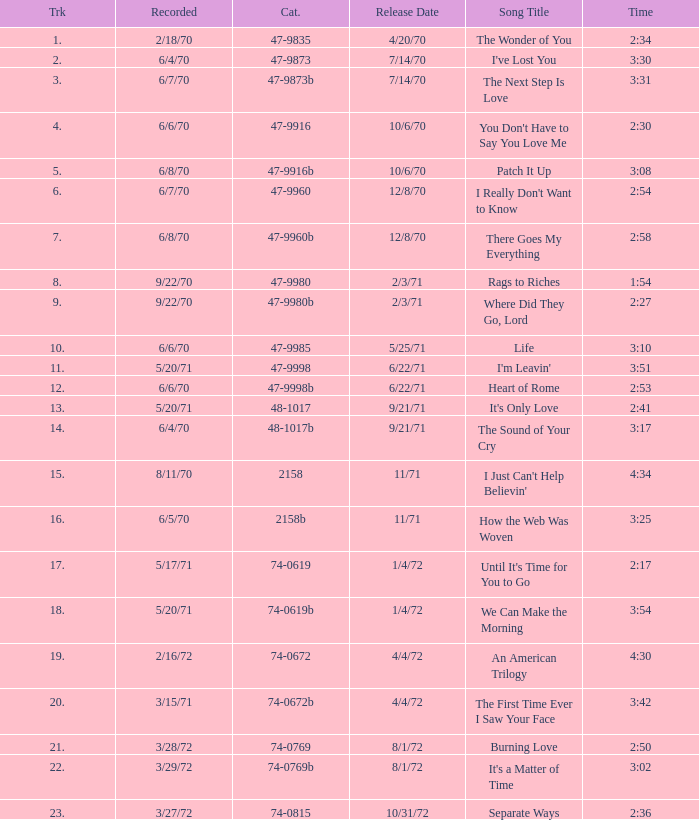What is Heart of Rome's catalogue number? 47-9998b. 